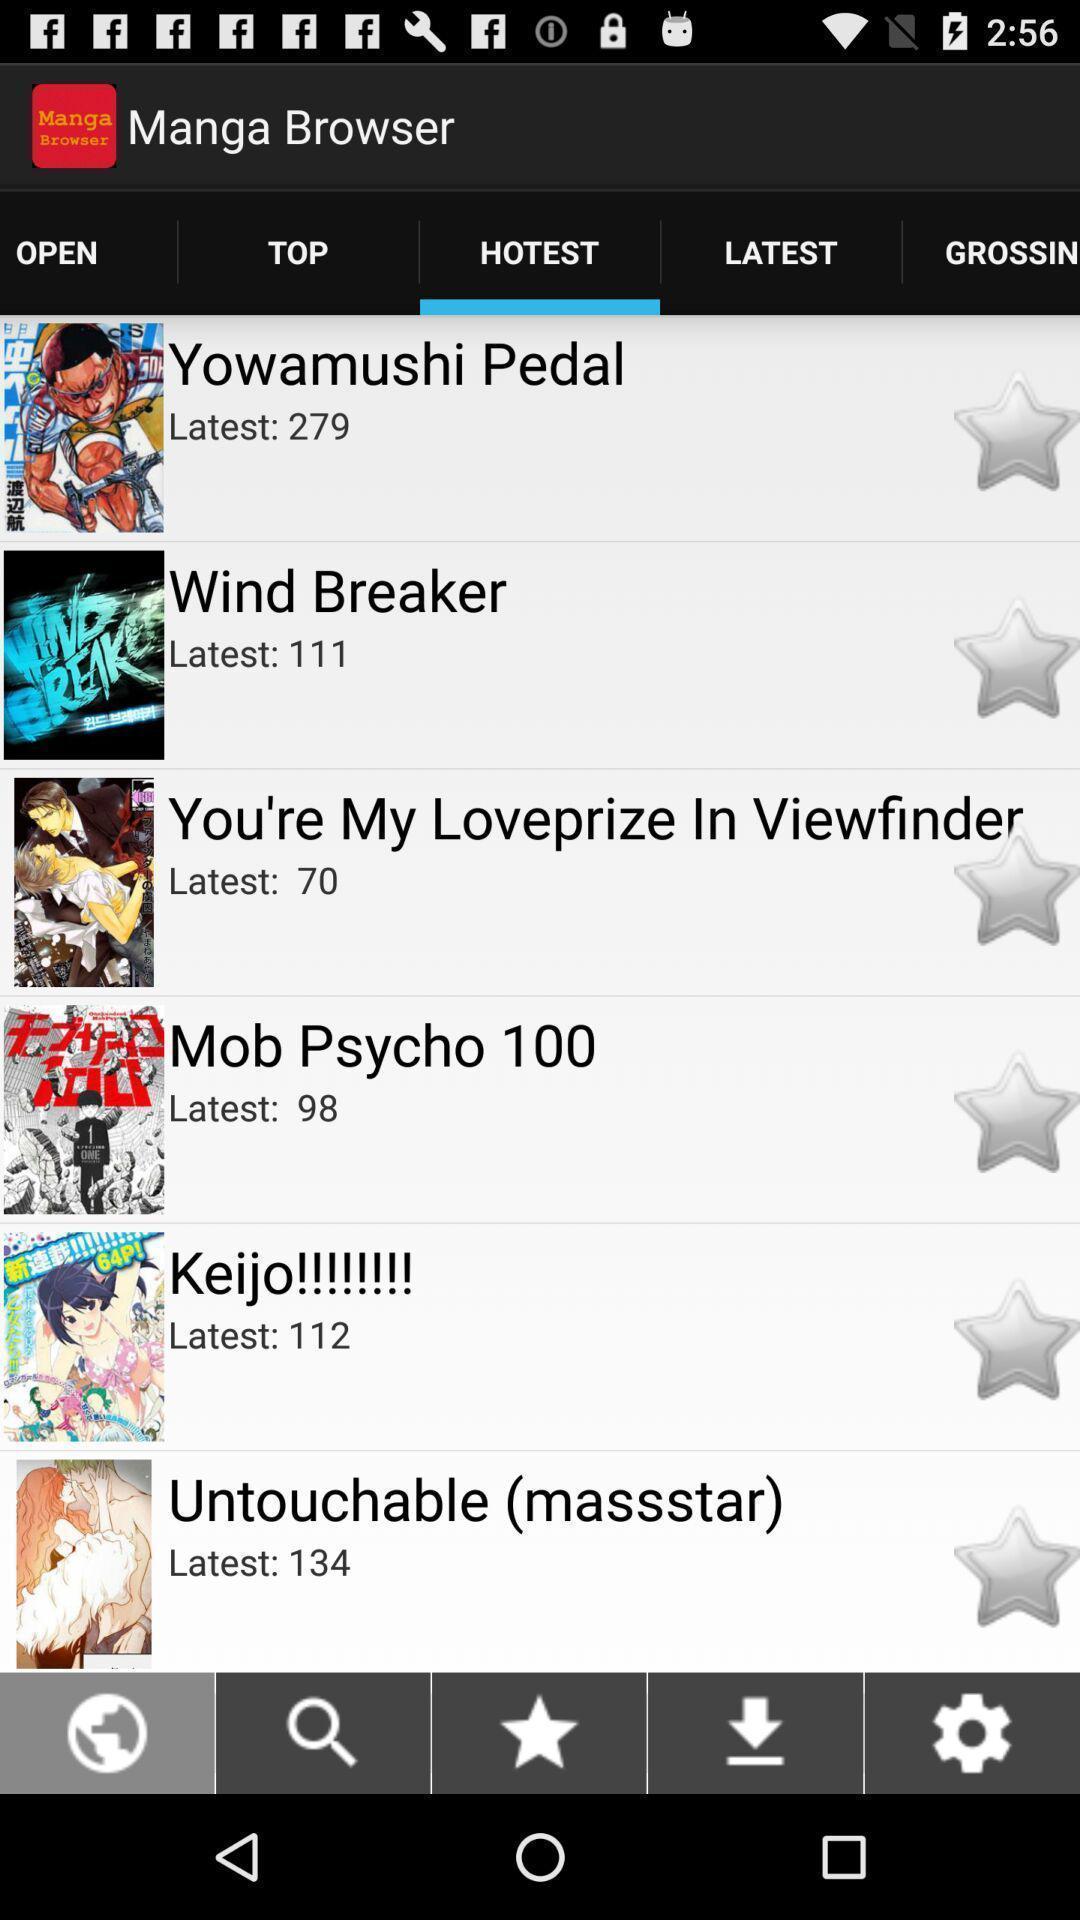Give me a narrative description of this picture. Page for the manga browser and other options. 